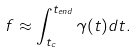<formula> <loc_0><loc_0><loc_500><loc_500>f \approx \int _ { t _ { c } } ^ { t _ { e n d } } \gamma ( t ) d t .</formula> 